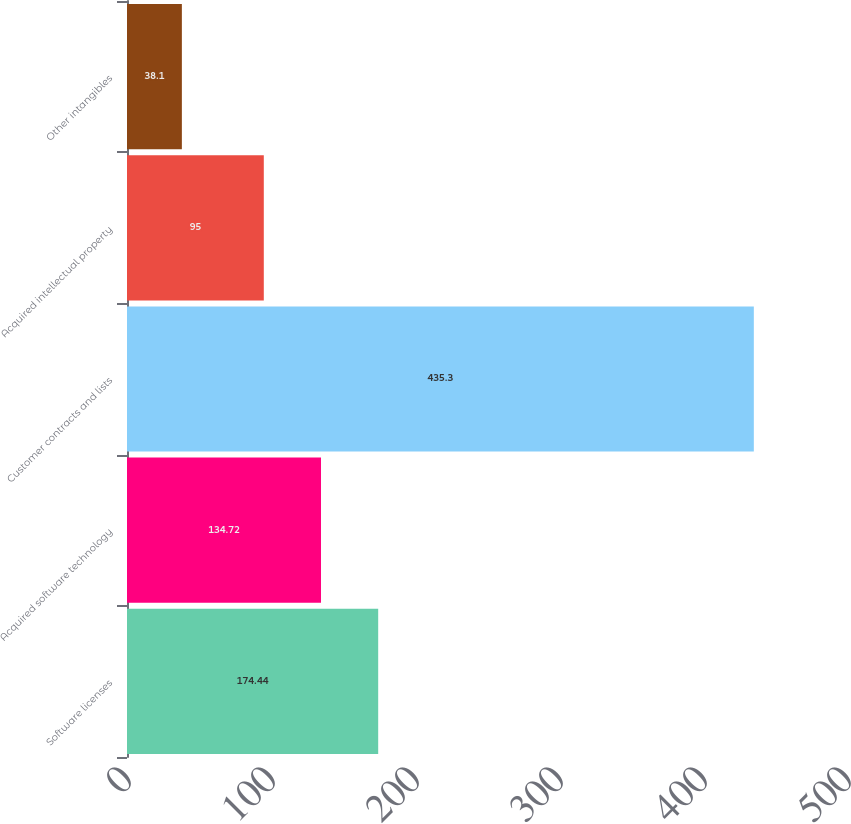<chart> <loc_0><loc_0><loc_500><loc_500><bar_chart><fcel>Software licenses<fcel>Acquired software technology<fcel>Customer contracts and lists<fcel>Acquired intellectual property<fcel>Other intangibles<nl><fcel>174.44<fcel>134.72<fcel>435.3<fcel>95<fcel>38.1<nl></chart> 